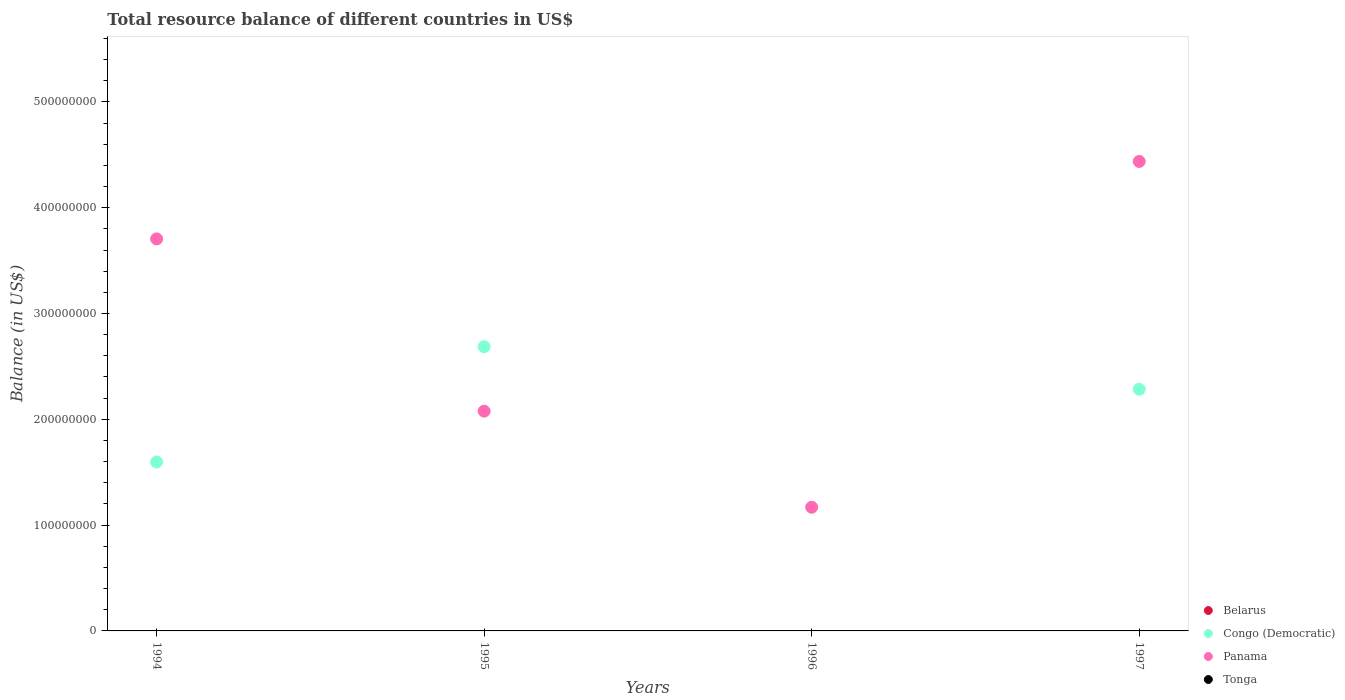Across all years, what is the maximum total resource balance in Panama?
Make the answer very short. 4.44e+08. Across all years, what is the minimum total resource balance in Panama?
Keep it short and to the point. 1.17e+08. What is the total total resource balance in Panama in the graph?
Give a very brief answer. 1.14e+09. What is the difference between the total resource balance in Panama in 1994 and that in 1997?
Your answer should be compact. -7.32e+07. What is the difference between the total resource balance in Belarus in 1994 and the total resource balance in Panama in 1995?
Provide a succinct answer. -2.08e+08. What is the average total resource balance in Panama per year?
Your response must be concise. 2.85e+08. In how many years, is the total resource balance in Tonga greater than 420000000 US$?
Your answer should be very brief. 0. What is the ratio of the total resource balance in Congo (Democratic) in 1995 to that in 1997?
Offer a terse response. 1.18. What is the difference between the highest and the second highest total resource balance in Congo (Democratic)?
Give a very brief answer. 4.02e+07. What is the difference between the highest and the lowest total resource balance in Congo (Democratic)?
Offer a very short reply. 2.69e+08. Is the sum of the total resource balance in Congo (Democratic) in 1994 and 1995 greater than the maximum total resource balance in Panama across all years?
Give a very brief answer. No. Is it the case that in every year, the sum of the total resource balance in Congo (Democratic) and total resource balance in Tonga  is greater than the sum of total resource balance in Panama and total resource balance in Belarus?
Your answer should be compact. No. Is it the case that in every year, the sum of the total resource balance in Belarus and total resource balance in Panama  is greater than the total resource balance in Tonga?
Your answer should be compact. Yes. Is the total resource balance in Belarus strictly less than the total resource balance in Congo (Democratic) over the years?
Make the answer very short. Yes. How many dotlines are there?
Ensure brevity in your answer.  2. How many years are there in the graph?
Offer a terse response. 4. What is the difference between two consecutive major ticks on the Y-axis?
Offer a very short reply. 1.00e+08. Are the values on the major ticks of Y-axis written in scientific E-notation?
Give a very brief answer. No. Does the graph contain any zero values?
Provide a short and direct response. Yes. Does the graph contain grids?
Offer a terse response. No. What is the title of the graph?
Give a very brief answer. Total resource balance of different countries in US$. Does "Cyprus" appear as one of the legend labels in the graph?
Keep it short and to the point. No. What is the label or title of the X-axis?
Make the answer very short. Years. What is the label or title of the Y-axis?
Make the answer very short. Balance (in US$). What is the Balance (in US$) in Congo (Democratic) in 1994?
Provide a succinct answer. 1.60e+08. What is the Balance (in US$) of Panama in 1994?
Provide a short and direct response. 3.70e+08. What is the Balance (in US$) of Tonga in 1994?
Your answer should be very brief. 0. What is the Balance (in US$) of Congo (Democratic) in 1995?
Provide a succinct answer. 2.69e+08. What is the Balance (in US$) in Panama in 1995?
Your answer should be very brief. 2.08e+08. What is the Balance (in US$) of Tonga in 1995?
Your response must be concise. 0. What is the Balance (in US$) of Panama in 1996?
Your response must be concise. 1.17e+08. What is the Balance (in US$) in Congo (Democratic) in 1997?
Your answer should be compact. 2.28e+08. What is the Balance (in US$) in Panama in 1997?
Offer a very short reply. 4.44e+08. Across all years, what is the maximum Balance (in US$) of Congo (Democratic)?
Your answer should be very brief. 2.69e+08. Across all years, what is the maximum Balance (in US$) of Panama?
Make the answer very short. 4.44e+08. Across all years, what is the minimum Balance (in US$) of Panama?
Provide a succinct answer. 1.17e+08. What is the total Balance (in US$) of Congo (Democratic) in the graph?
Give a very brief answer. 6.57e+08. What is the total Balance (in US$) of Panama in the graph?
Provide a short and direct response. 1.14e+09. What is the difference between the Balance (in US$) in Congo (Democratic) in 1994 and that in 1995?
Make the answer very short. -1.09e+08. What is the difference between the Balance (in US$) in Panama in 1994 and that in 1995?
Offer a terse response. 1.63e+08. What is the difference between the Balance (in US$) in Panama in 1994 and that in 1996?
Offer a very short reply. 2.54e+08. What is the difference between the Balance (in US$) in Congo (Democratic) in 1994 and that in 1997?
Give a very brief answer. -6.87e+07. What is the difference between the Balance (in US$) in Panama in 1994 and that in 1997?
Keep it short and to the point. -7.32e+07. What is the difference between the Balance (in US$) of Panama in 1995 and that in 1996?
Offer a very short reply. 9.08e+07. What is the difference between the Balance (in US$) in Congo (Democratic) in 1995 and that in 1997?
Give a very brief answer. 4.02e+07. What is the difference between the Balance (in US$) of Panama in 1995 and that in 1997?
Offer a terse response. -2.36e+08. What is the difference between the Balance (in US$) of Panama in 1996 and that in 1997?
Provide a succinct answer. -3.27e+08. What is the difference between the Balance (in US$) in Congo (Democratic) in 1994 and the Balance (in US$) in Panama in 1995?
Offer a terse response. -4.80e+07. What is the difference between the Balance (in US$) in Congo (Democratic) in 1994 and the Balance (in US$) in Panama in 1996?
Ensure brevity in your answer.  4.28e+07. What is the difference between the Balance (in US$) in Congo (Democratic) in 1994 and the Balance (in US$) in Panama in 1997?
Provide a succinct answer. -2.84e+08. What is the difference between the Balance (in US$) in Congo (Democratic) in 1995 and the Balance (in US$) in Panama in 1996?
Provide a short and direct response. 1.52e+08. What is the difference between the Balance (in US$) of Congo (Democratic) in 1995 and the Balance (in US$) of Panama in 1997?
Your answer should be compact. -1.75e+08. What is the average Balance (in US$) in Belarus per year?
Offer a terse response. 0. What is the average Balance (in US$) of Congo (Democratic) per year?
Give a very brief answer. 1.64e+08. What is the average Balance (in US$) in Panama per year?
Make the answer very short. 2.85e+08. In the year 1994, what is the difference between the Balance (in US$) in Congo (Democratic) and Balance (in US$) in Panama?
Your response must be concise. -2.11e+08. In the year 1995, what is the difference between the Balance (in US$) in Congo (Democratic) and Balance (in US$) in Panama?
Provide a short and direct response. 6.09e+07. In the year 1997, what is the difference between the Balance (in US$) of Congo (Democratic) and Balance (in US$) of Panama?
Your answer should be very brief. -2.15e+08. What is the ratio of the Balance (in US$) of Congo (Democratic) in 1994 to that in 1995?
Give a very brief answer. 0.59. What is the ratio of the Balance (in US$) in Panama in 1994 to that in 1995?
Your answer should be very brief. 1.78. What is the ratio of the Balance (in US$) in Panama in 1994 to that in 1996?
Offer a very short reply. 3.17. What is the ratio of the Balance (in US$) of Congo (Democratic) in 1994 to that in 1997?
Make the answer very short. 0.7. What is the ratio of the Balance (in US$) of Panama in 1994 to that in 1997?
Your answer should be very brief. 0.83. What is the ratio of the Balance (in US$) in Panama in 1995 to that in 1996?
Keep it short and to the point. 1.78. What is the ratio of the Balance (in US$) of Congo (Democratic) in 1995 to that in 1997?
Keep it short and to the point. 1.18. What is the ratio of the Balance (in US$) of Panama in 1995 to that in 1997?
Ensure brevity in your answer.  0.47. What is the ratio of the Balance (in US$) in Panama in 1996 to that in 1997?
Provide a short and direct response. 0.26. What is the difference between the highest and the second highest Balance (in US$) in Congo (Democratic)?
Your response must be concise. 4.02e+07. What is the difference between the highest and the second highest Balance (in US$) of Panama?
Keep it short and to the point. 7.32e+07. What is the difference between the highest and the lowest Balance (in US$) in Congo (Democratic)?
Make the answer very short. 2.69e+08. What is the difference between the highest and the lowest Balance (in US$) in Panama?
Make the answer very short. 3.27e+08. 